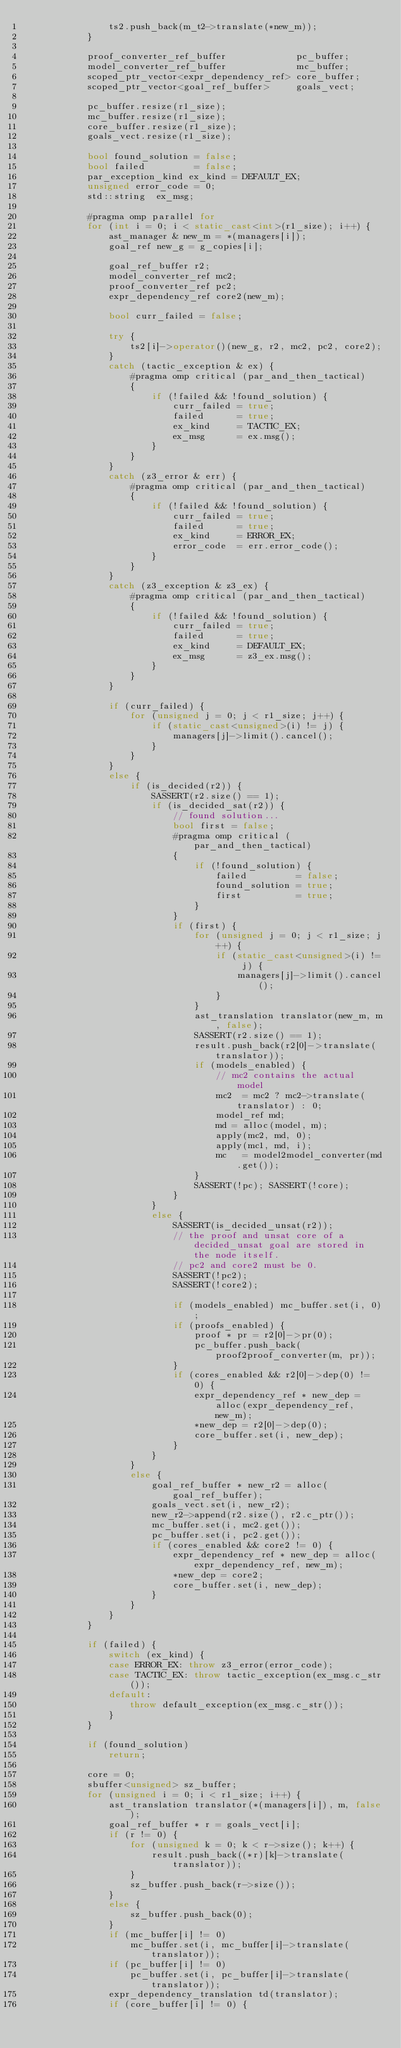Convert code to text. <code><loc_0><loc_0><loc_500><loc_500><_C++_>                ts2.push_back(m_t2->translate(*new_m));
            }

            proof_converter_ref_buffer             pc_buffer; 
            model_converter_ref_buffer             mc_buffer; 
            scoped_ptr_vector<expr_dependency_ref> core_buffer;
            scoped_ptr_vector<goal_ref_buffer>     goals_vect;

            pc_buffer.resize(r1_size);
            mc_buffer.resize(r1_size);
            core_buffer.resize(r1_size);
            goals_vect.resize(r1_size);

            bool found_solution = false;
            bool failed         = false;
            par_exception_kind ex_kind = DEFAULT_EX;
            unsigned error_code = 0;
            std::string  ex_msg;

            #pragma omp parallel for
            for (int i = 0; i < static_cast<int>(r1_size); i++) { 
                ast_manager & new_m = *(managers[i]);
                goal_ref new_g = g_copies[i];

                goal_ref_buffer r2;
                model_converter_ref mc2;                                                                   
                proof_converter_ref pc2;                                                                   
                expr_dependency_ref core2(new_m);                                                              
                
                bool curr_failed = false;

                try {
                    ts2[i]->operator()(new_g, r2, mc2, pc2, core2);                                              
                }
                catch (tactic_exception & ex) {
                    #pragma omp critical (par_and_then_tactical)
                    {
                        if (!failed && !found_solution) {
                            curr_failed = true;
                            failed      = true;
                            ex_kind     = TACTIC_EX;
                            ex_msg      = ex.msg();
                        }
                    }
                }
                catch (z3_error & err) {
                    #pragma omp critical (par_and_then_tactical)
                    {
                        if (!failed && !found_solution) {
                            curr_failed = true;
                            failed      = true;
                            ex_kind     = ERROR_EX;
                            error_code  = err.error_code();
                        }
                    }                    
                }
                catch (z3_exception & z3_ex) {
                    #pragma omp critical (par_and_then_tactical)
                    {
                        if (!failed && !found_solution) {
                            curr_failed = true;
                            failed      = true;
                            ex_kind     = DEFAULT_EX;
                            ex_msg      = z3_ex.msg();
                        }
                    }
                }

                if (curr_failed) {
                    for (unsigned j = 0; j < r1_size; j++) {
                        if (static_cast<unsigned>(i) != j) {
                            managers[j]->limit().cancel();
                        }
                    }
                }
                else {
                    if (is_decided(r2)) {
                        SASSERT(r2.size() == 1);
                        if (is_decided_sat(r2)) {                                                          
                            // found solution... 
                            bool first = false;
                            #pragma omp critical (par_and_then_tactical)
                            {
                                if (!found_solution) {
                                    failed         = false;
                                    found_solution = true;
                                    first          = true;
                                }
                            }
                            if (first) {
                                for (unsigned j = 0; j < r1_size; j++) {
                                    if (static_cast<unsigned>(i) != j) {
                                        managers[j]->limit().cancel();
                                    }
                                }
                                ast_translation translator(new_m, m, false);
                                SASSERT(r2.size() == 1);
                                result.push_back(r2[0]->translate(translator));
                                if (models_enabled) {
                                    // mc2 contains the actual model                                                    
                                    mc2  = mc2 ? mc2->translate(translator) : 0;
                                    model_ref md;     
                                    md = alloc(model, m);
                                    apply(mc2, md, 0);
                                    apply(mc1, md, i);
                                    mc   = model2model_converter(md.get());
                                }
                                SASSERT(!pc); SASSERT(!core);
                            }       
                        }                                                     
                        else {                                                                                  
                            SASSERT(is_decided_unsat(r2));                                                 
                            // the proof and unsat core of a decided_unsat goal are stored in the node itself.
                            // pc2 and core2 must be 0.
                            SASSERT(!pc2);
                            SASSERT(!core2);
                            
                            if (models_enabled) mc_buffer.set(i, 0);
                            if (proofs_enabled) {
                                proof * pr = r2[0]->pr(0);
                                pc_buffer.push_back(proof2proof_converter(m, pr));
                            }
                            if (cores_enabled && r2[0]->dep(0) != 0) {
                                expr_dependency_ref * new_dep = alloc(expr_dependency_ref, new_m);
                                *new_dep = r2[0]->dep(0);
                                core_buffer.set(i, new_dep);
                            }
                        }                                                                 
                    }                                                                                       
                    else {                                                                                      
                        goal_ref_buffer * new_r2 = alloc(goal_ref_buffer);
                        goals_vect.set(i, new_r2);
                        new_r2->append(r2.size(), r2.c_ptr());
                        mc_buffer.set(i, mc2.get());
                        pc_buffer.set(i, pc2.get());
                        if (cores_enabled && core2 != 0) {
                            expr_dependency_ref * new_dep = alloc(expr_dependency_ref, new_m);
                            *new_dep = core2;
                            core_buffer.set(i, new_dep);
                        }
                    }                                                                                           
                }
            }
            
            if (failed) {
                switch (ex_kind) {
                case ERROR_EX: throw z3_error(error_code);
                case TACTIC_EX: throw tactic_exception(ex_msg.c_str());
                default:
                    throw default_exception(ex_msg.c_str());
                }
            }

            if (found_solution)
                return;

            core = 0;
            sbuffer<unsigned> sz_buffer;                                                           
            for (unsigned i = 0; i < r1_size; i++) {
                ast_translation translator(*(managers[i]), m, false);
                goal_ref_buffer * r = goals_vect[i];
                if (r != 0) {
                    for (unsigned k = 0; k < r->size(); k++) {
                        result.push_back((*r)[k]->translate(translator));
                    }
                    sz_buffer.push_back(r->size());
                }
                else {
                    sz_buffer.push_back(0);
                }
                if (mc_buffer[i] != 0)
                    mc_buffer.set(i, mc_buffer[i]->translate(translator));
                if (pc_buffer[i] != 0)
                    pc_buffer.set(i, pc_buffer[i]->translate(translator));
                expr_dependency_translation td(translator);
                if (core_buffer[i] != 0) {</code> 